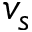<formula> <loc_0><loc_0><loc_500><loc_500>v _ { s }</formula> 